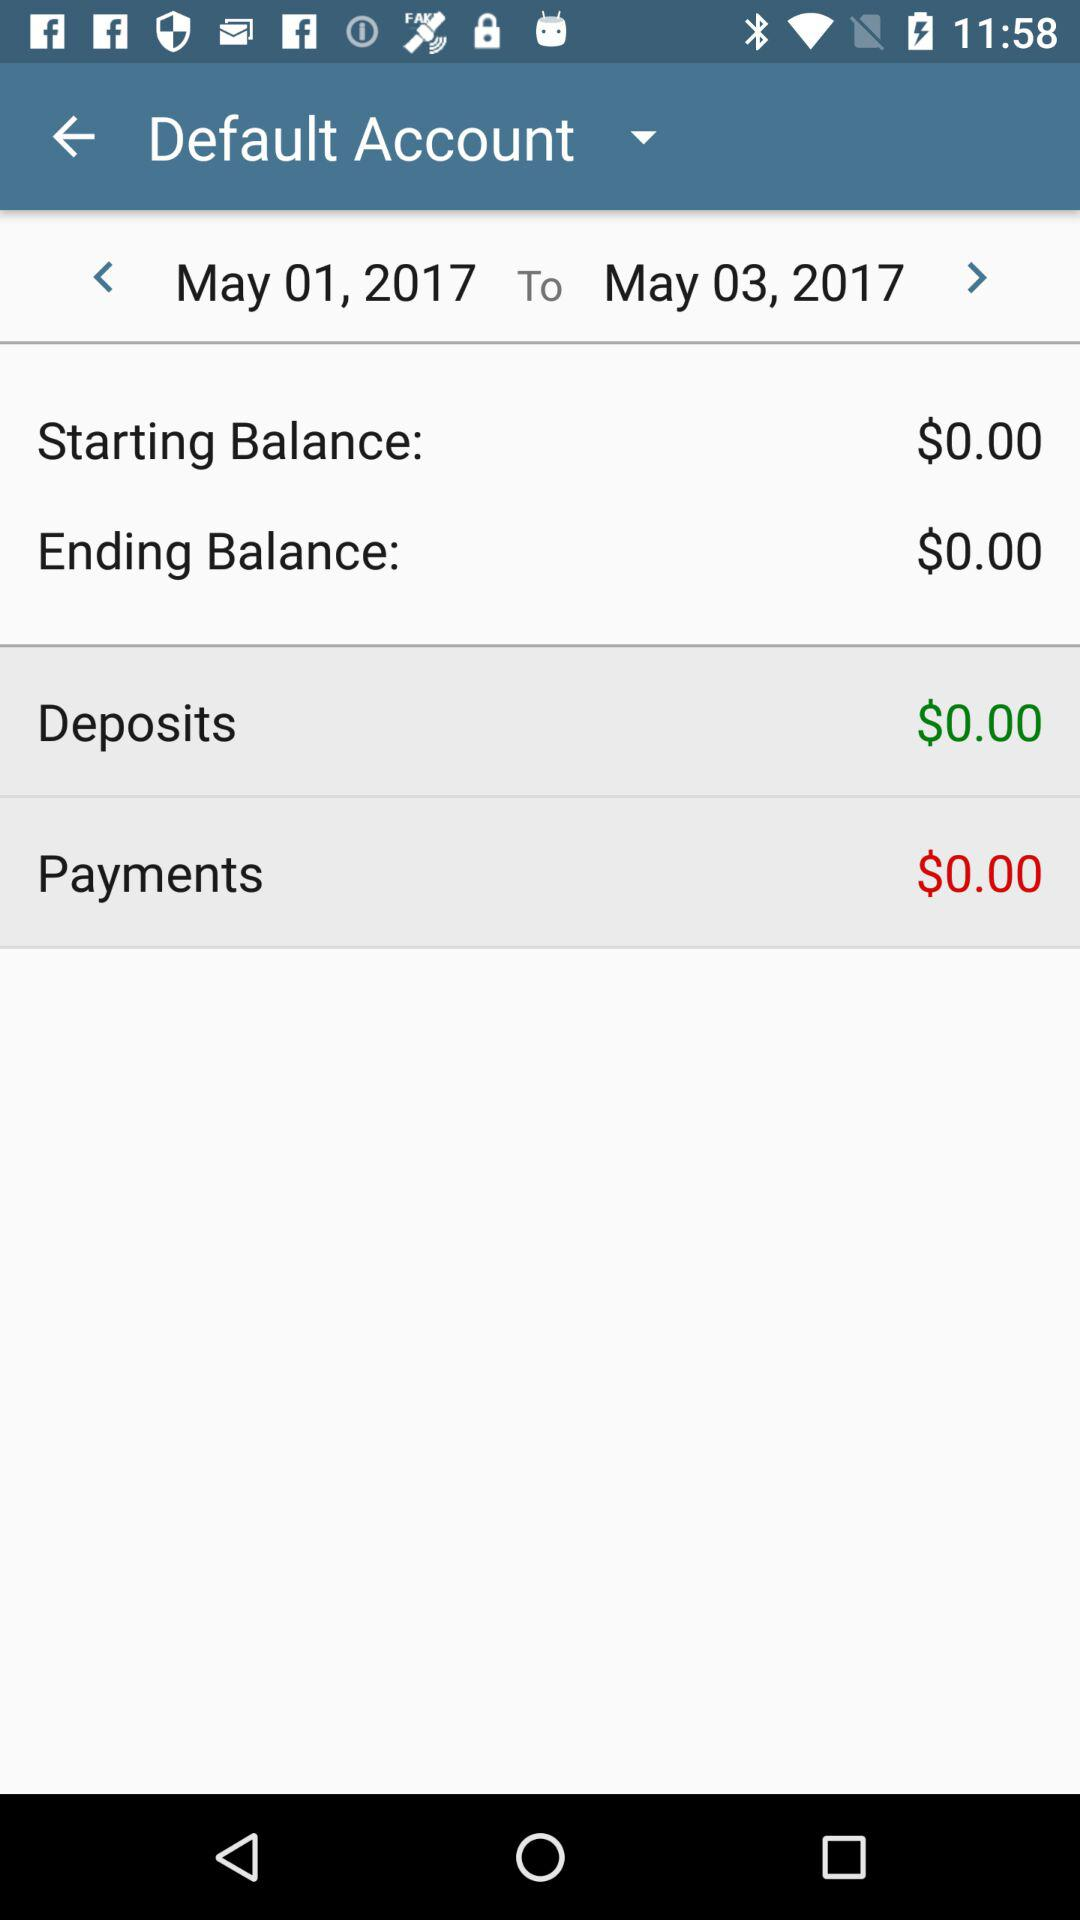What is the difference between the starting and ending balances?
Answer the question using a single word or phrase. $0.00 